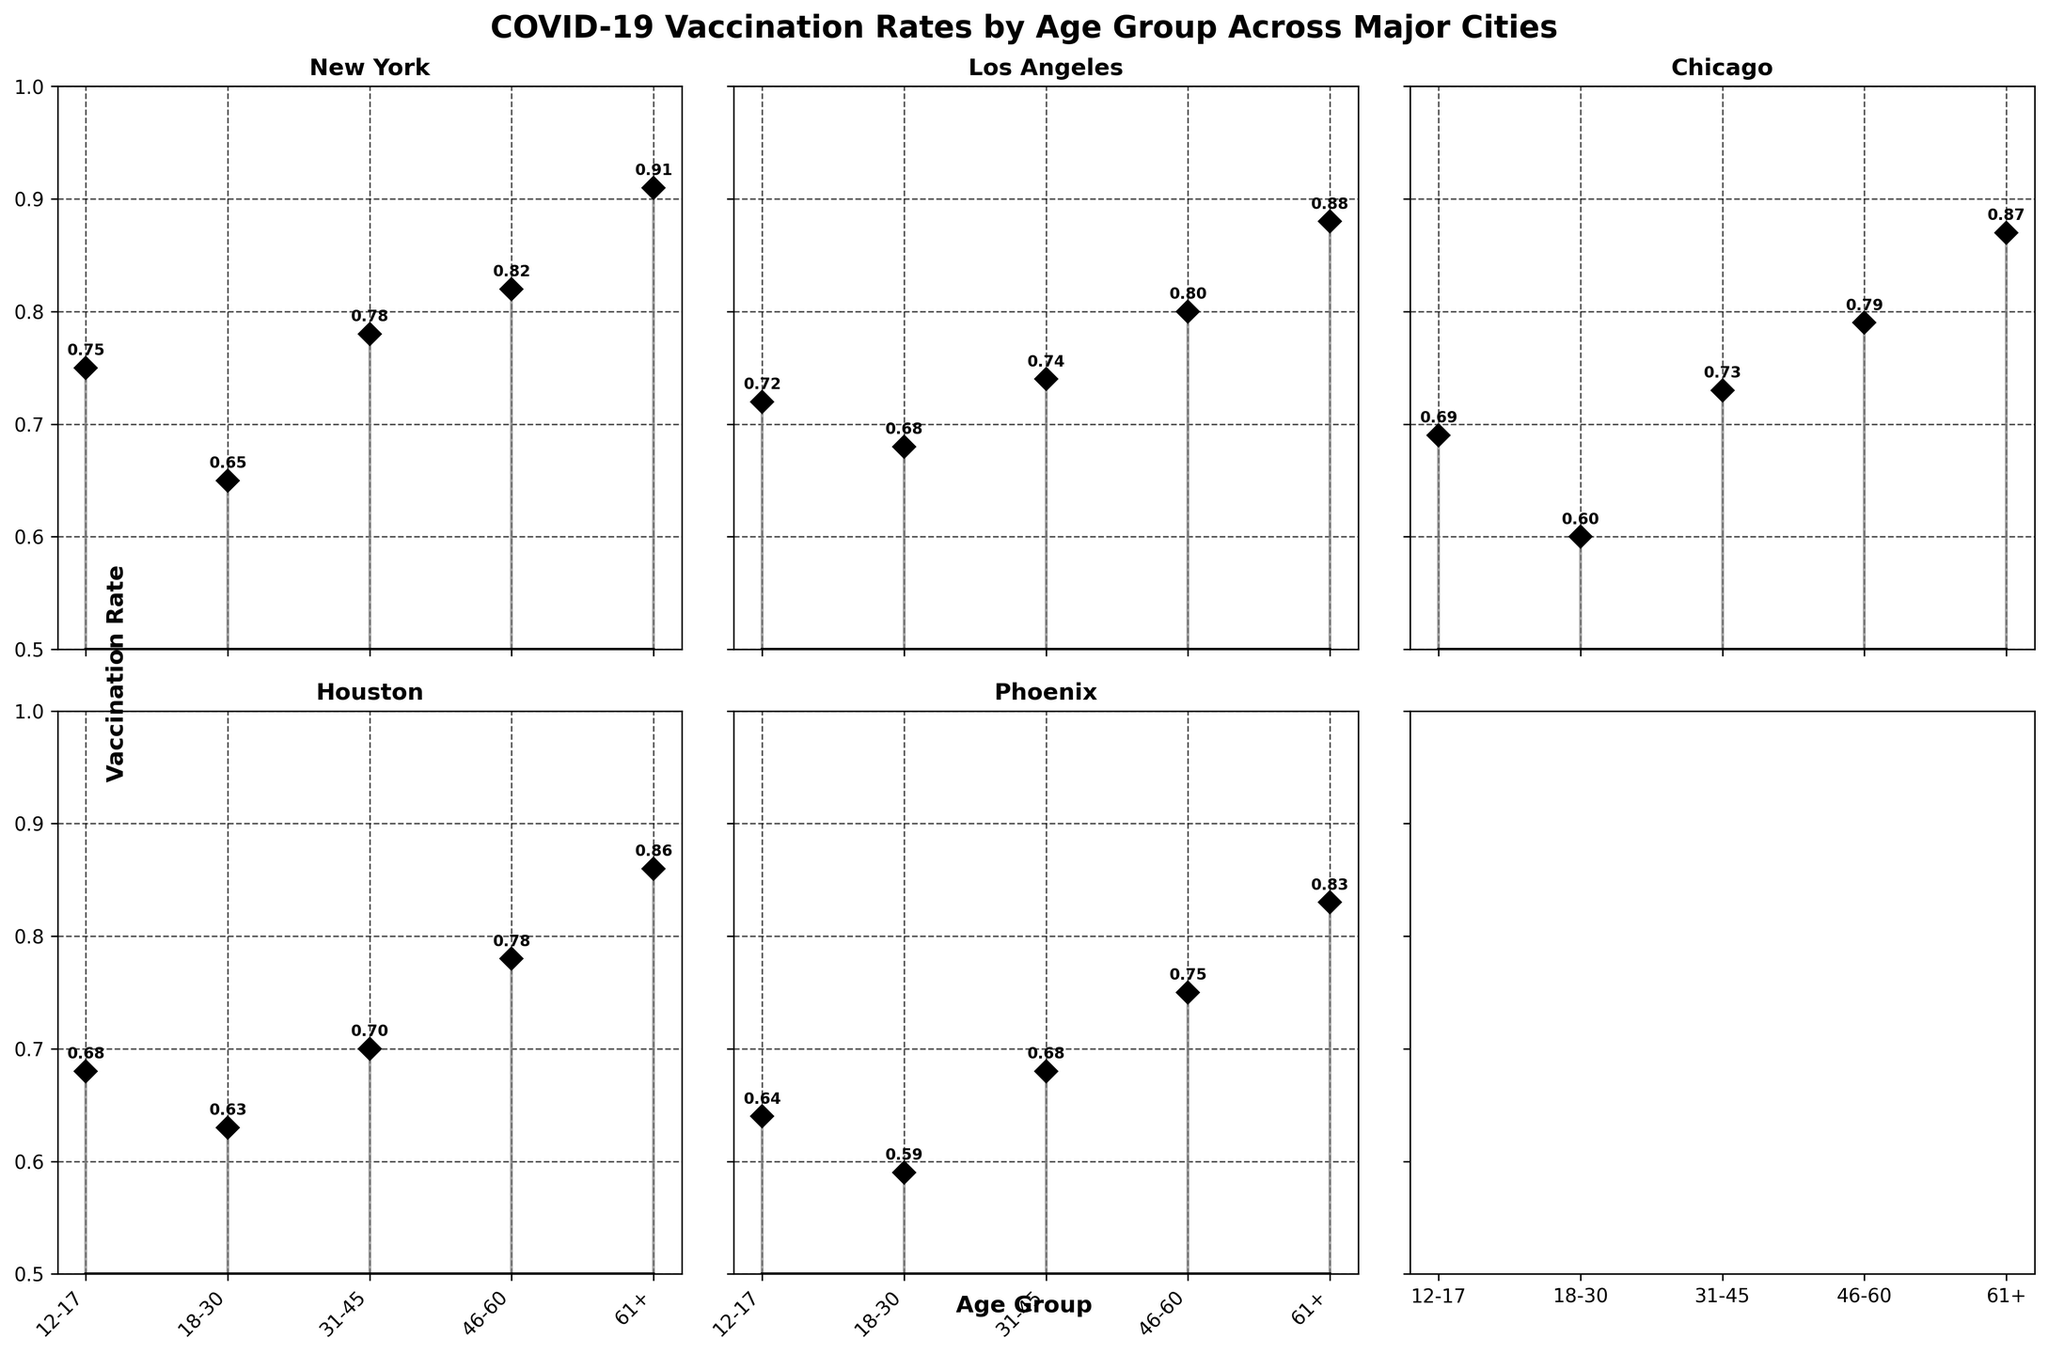What's the title of the figure? The title is usually displayed at the top of the figure. In this case, it is bold and centralized.
Answer: COVID-19 Vaccination Rates by Age Group Across Major Cities Which city has the highest vaccination rate for the age group 61+? Comparing the stem plots of the 61+ age group across all cities, you can see which one has the highest value by comparing the heights of the markers.
Answer: New York What is the vaccination rate for the 18-30 age group in Los Angeles? Look at the stem plot segment for Los Angeles, read the marker height/label for the 18-30 age group.
Answer: 0.68 Which city has the lowest vaccination rate for the 12-17 age group? Look at the stem plots for each city, compare the heights of the markers for the 12-17 age group, and identify the lowest one.
Answer: Phoenix What's the average vaccination rate for the age group 46-60 across all cities? Summing the vaccination rates for 46-60 age group across all cities (New York: 0.82, Los Angeles: 0.80, Chicago: 0.79, Houston: 0.78, Phoenix: 0.75) and dividing by the number of cities (5) gives the average.
Answer: (0.82 + 0.80 + 0.79 + 0.78 + 0.75) / 5 = 0.788 Which city shows the lowest vaccination rate among the age groups displayed in the figure? Identify the lowest marker across all age groups and cities in the stem plots.
Answer: Phoenix How does the vaccination rate for Houston in the age group 31-45 compare to Chicago in the same age group? Compare the markers for the 31-45 age group in Houston and Chicago, note the values and the relation.
Answer: Houston is lower than Chicago What is the difference in vaccination rates for the 12-17 age group between New York and Phoenix? Subtract Phoenix's rate from New York's rate for the 12-17 age group: 0.75 - 0.64.
Answer: 0.11 Which age group in New York has the closest vaccination rate to 0.80? Compare the vaccination rates for each age group in New York to 0.80, and find the closest value.
Answer: 46-60 Identify the age group with the highest vaccination rate variability across all cities. Look at the stem plots for each age group across the cities, and note the range and differences in values.
Answer: 12-17 